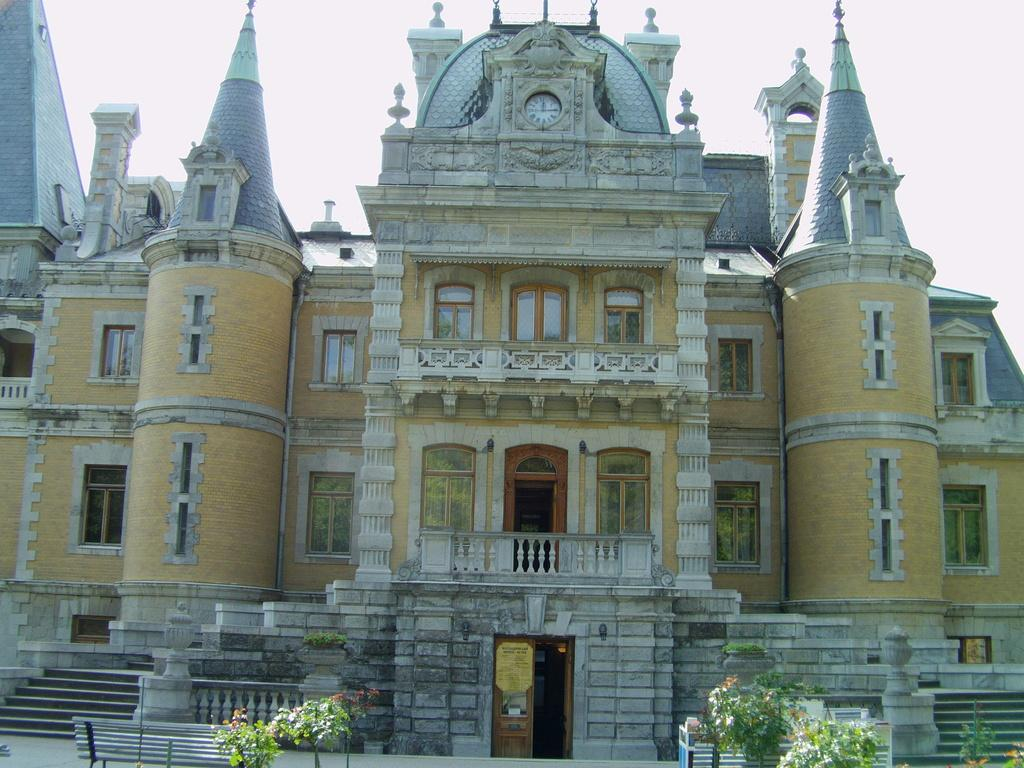What is located at the bottom of the image? There are plants, benches, and steps at the bottom of the image. What can be seen on the doors in the image? There is a board on the doors in the image. What structures are visible in the background of the image? There is a building, windows, doors, and fences in the background of the image. What part of the natural environment is visible in the image? The sky is visible in the background of the image. How does the self-driving car navigate the quiet streets in the image? There is no self-driving car or mention of streets in the image; it features plants, benches, steps, a building, windows, doors, fences, and the sky. What type of moon can be seen in the image? There is no moon present in the image. 